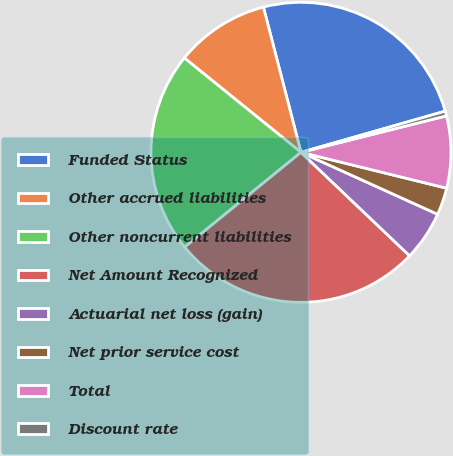Convert chart. <chart><loc_0><loc_0><loc_500><loc_500><pie_chart><fcel>Funded Status<fcel>Other accrued liabilities<fcel>Other noncurrent liabilities<fcel>Net Amount Recognized<fcel>Actuarial net loss (gain)<fcel>Net prior service cost<fcel>Total<fcel>Discount rate<nl><fcel>24.6%<fcel>10.15%<fcel>21.71%<fcel>27.0%<fcel>5.34%<fcel>2.93%<fcel>7.75%<fcel>0.52%<nl></chart> 